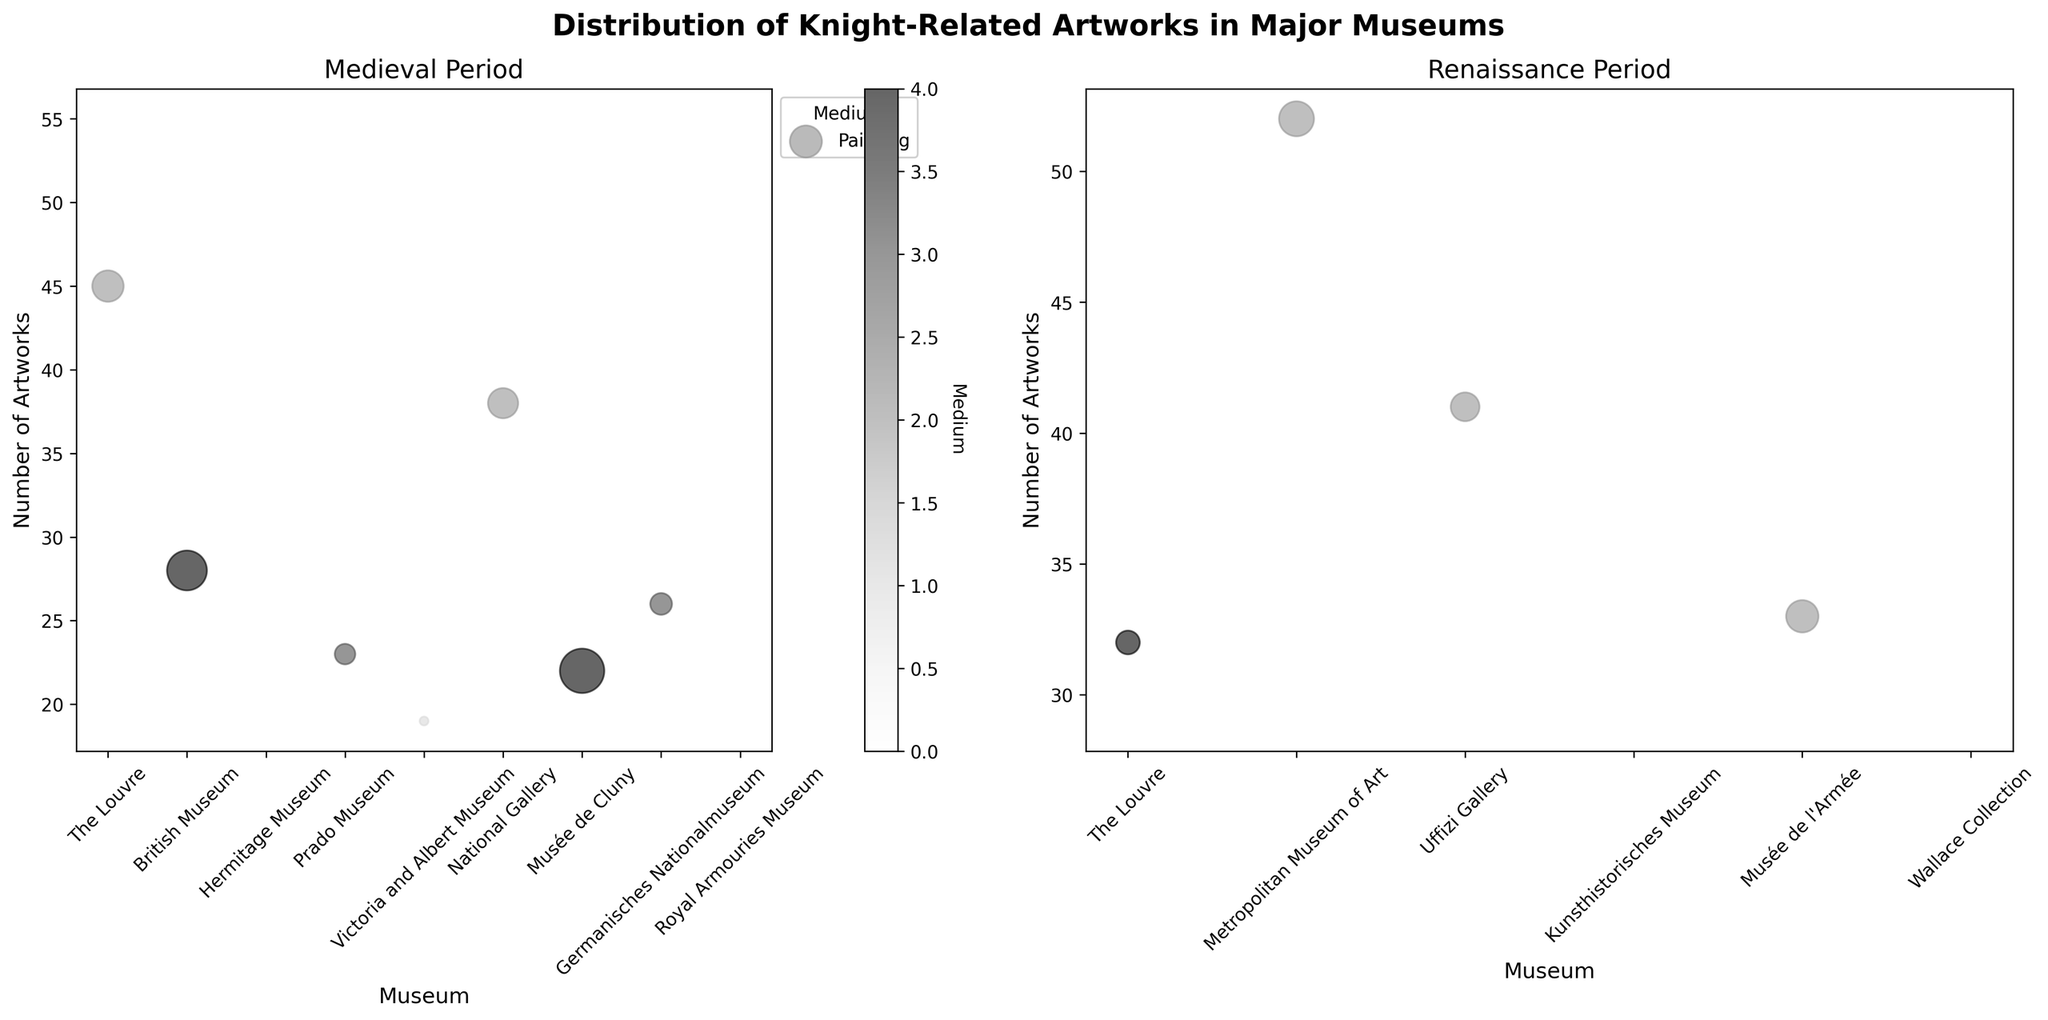What is the title of the subplot figure? To find the title of the subplot figure, look at the top section of the figure.
Answer: Distribution of Knight-Related Artworks in Major Museums Which museum has the highest number of artworks from the Medieval period? Identify the highest data point on the y-axis in the Medieval period subplot and find the corresponding museum on the x-axis.
Answer: Royal Armouries Museum What medium is represented by the largest bubble in the Renaissance period subplot? In the Renaissance period subplot, look for the largest bubble by size, and check the legend for the corresponding color to identify the medium.
Answer: Painting What is the range of the number of artworks displayed by museums during the Medieval period? Find the minimum and maximum data points on the y-axis of the Medieval period subplot to determine the range.
Answer: 19 to 55 Which period, Medieval or Renaissance, has a museum with the artwork with the highest average size? Compare the data points in both subplots and check the sizes of the bubbles. The largest bubble indicates the highest average size.
Answer: Medieval How many museums feature tapestries from the Medieval period? Count the number of bubbles labeled as tapestries in the Medieval period subplot using the legend for reference.
Answer: 2 How does the average size of armor artworks at the Royal Armouries Museum compare to that at the Hermitage Museum during the Medieval period? Find and compare the sizes of the bubbles representing armor at both museums in the Medieval period subplot. The larger bubble indicates the larger average size.
Answer: Smaller Which medium shows the least variation in bubble size in the Renaissance period? Identify the medium with the most uniform bubbles by size in the Renaissance period subplot using the legend for color reference.
Answer: Armor Which museum has the second-highest number of paintings from the Renaissance period? Identify and count the bubbles representing paintings in the Renaissance subplot, then find the museum with the second-highest y-value.
Answer: Uffizi Gallery What is the average number of artworks for museums with illuminated manuscripts from the Medieval period? Identify the bubbles for illuminated manuscripts in the Medieval subplot using the legend, then find the average of their y-values.
Answer: 19 